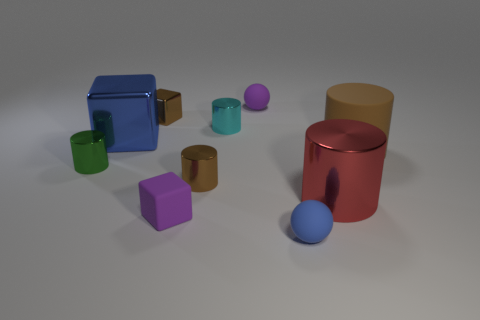What is the material of the blue thing that is behind the big red shiny thing?
Ensure brevity in your answer.  Metal. The small metallic block is what color?
Your answer should be very brief. Brown. Does the matte object on the right side of the blue ball have the same size as the tiny blue sphere?
Your response must be concise. No. What is the material of the tiny cylinder that is to the left of the brown metallic thing that is behind the big blue shiny thing to the left of the small blue matte ball?
Keep it short and to the point. Metal. Does the small matte object behind the cyan shiny thing have the same color as the small thing in front of the purple matte block?
Ensure brevity in your answer.  No. What is the material of the blue thing to the left of the sphere in front of the tiny purple ball?
Offer a very short reply. Metal. What color is the shiny block that is the same size as the blue rubber ball?
Provide a succinct answer. Brown. There is a large blue shiny thing; is it the same shape as the tiny brown metal object that is behind the big metal block?
Provide a short and direct response. Yes. There is a rubber object that is the same color as the small matte block; what is its shape?
Provide a short and direct response. Sphere. There is a tiny purple rubber thing that is behind the large metallic thing to the right of the large metallic block; what number of brown matte objects are to the left of it?
Your answer should be very brief. 0. 